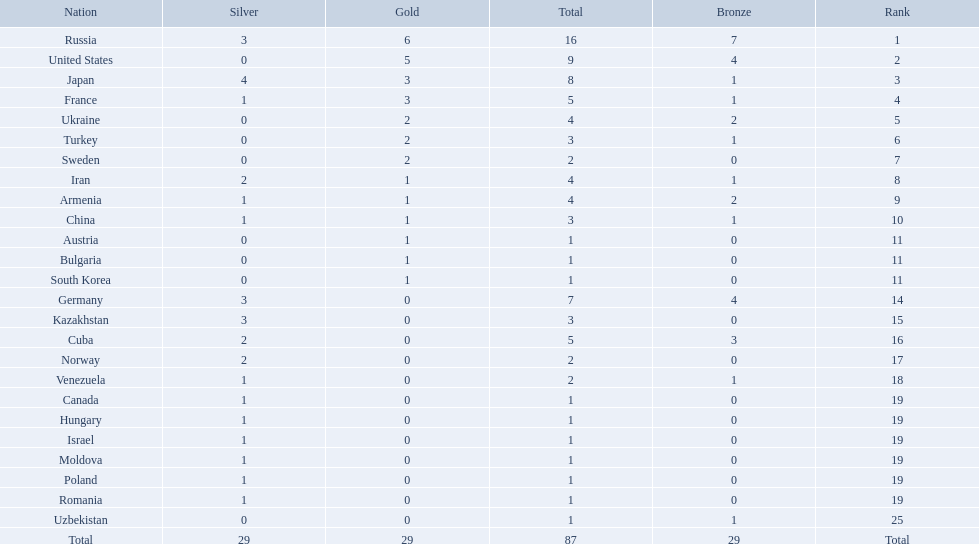Which nations participated in the 1995 world wrestling championships? Russia, United States, Japan, France, Ukraine, Turkey, Sweden, Iran, Armenia, China, Austria, Bulgaria, South Korea, Germany, Kazakhstan, Cuba, Norway, Venezuela, Canada, Hungary, Israel, Moldova, Poland, Romania, Uzbekistan. And between iran and germany, which one placed in the top 10? Germany. 